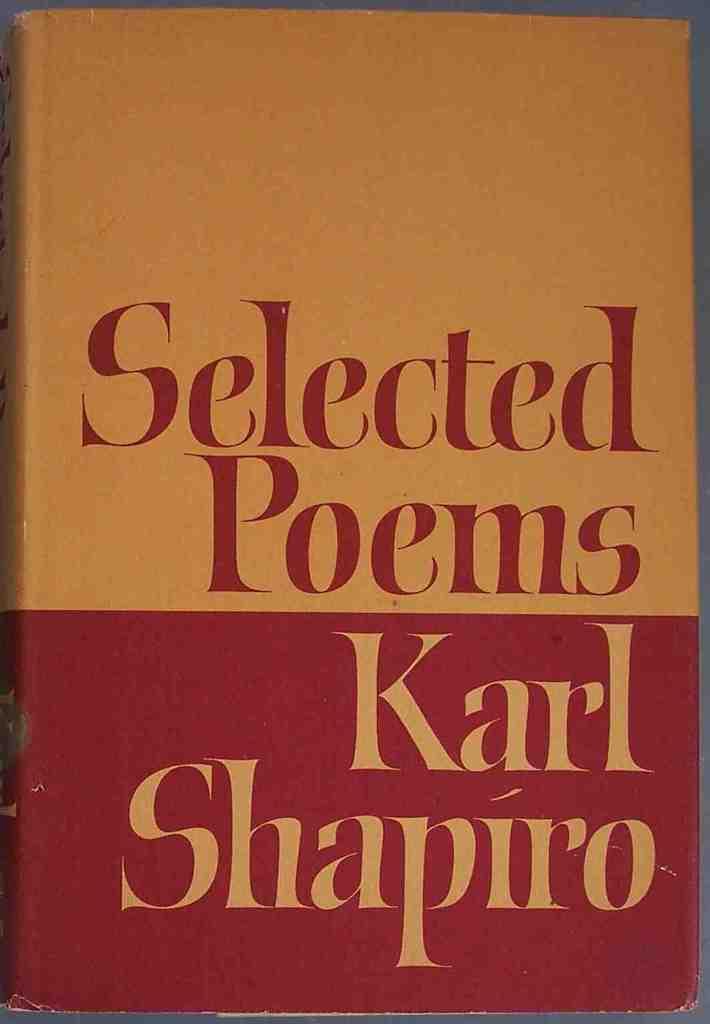What is this book about?
Provide a succinct answer. Poems. Who is the author?
Give a very brief answer. Karl shapiro. 